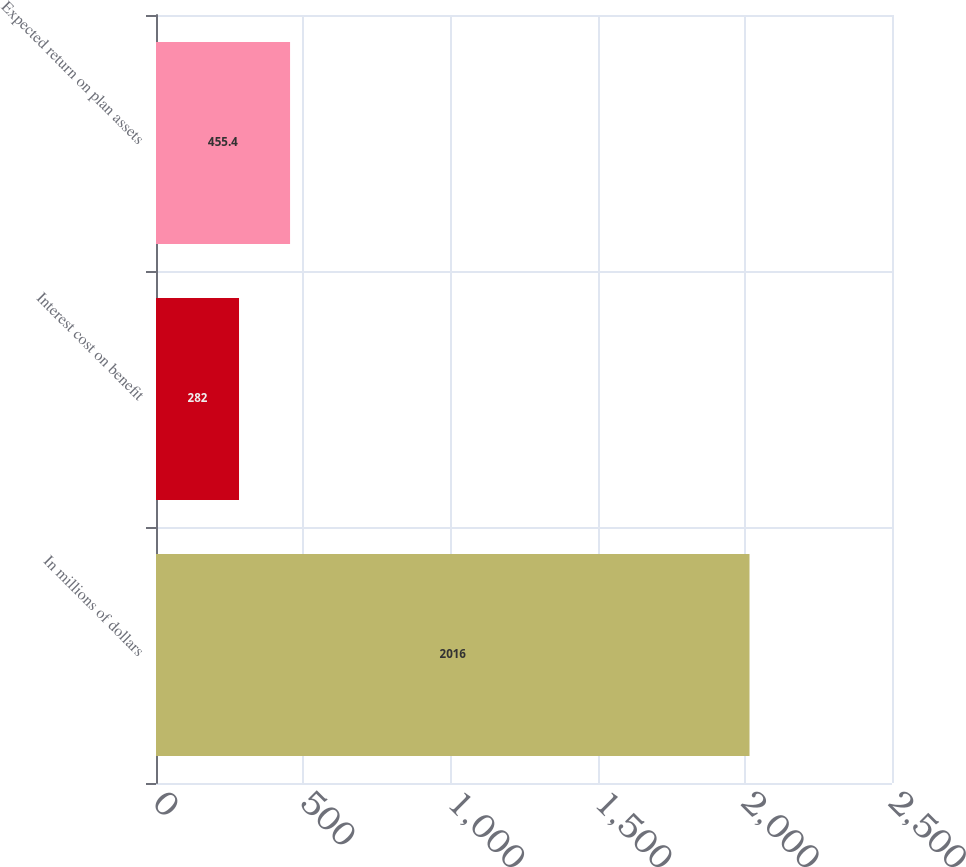Convert chart to OTSL. <chart><loc_0><loc_0><loc_500><loc_500><bar_chart><fcel>In millions of dollars<fcel>Interest cost on benefit<fcel>Expected return on plan assets<nl><fcel>2016<fcel>282<fcel>455.4<nl></chart> 